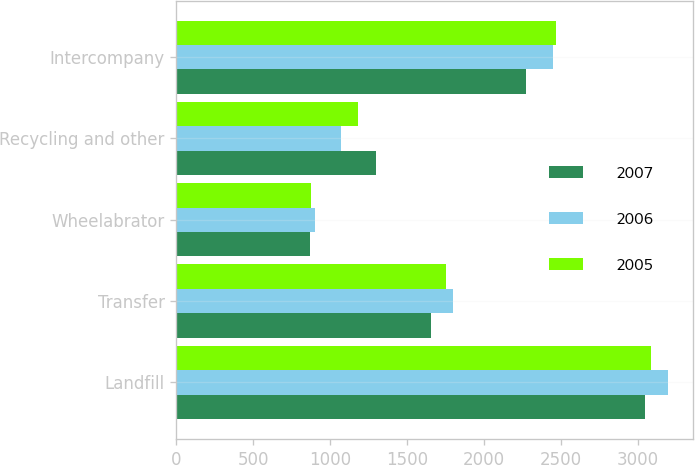<chart> <loc_0><loc_0><loc_500><loc_500><stacked_bar_chart><ecel><fcel>Landfill<fcel>Transfer<fcel>Wheelabrator<fcel>Recycling and other<fcel>Intercompany<nl><fcel>2007<fcel>3047<fcel>1654<fcel>868<fcel>1298<fcel>2271<nl><fcel>2006<fcel>3197<fcel>1802<fcel>902<fcel>1074<fcel>2449<nl><fcel>2005<fcel>3089<fcel>1756<fcel>879<fcel>1183<fcel>2466<nl></chart> 